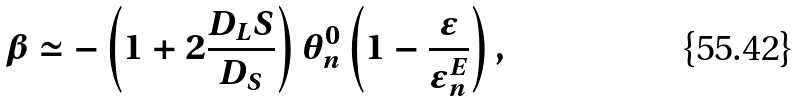Convert formula to latex. <formula><loc_0><loc_0><loc_500><loc_500>\beta \simeq - \left ( 1 + 2 \frac { D _ { L } S } { D _ { S } } \right ) \theta _ { n } ^ { 0 } \left ( 1 - \frac { \epsilon } { \epsilon _ { n } ^ { E } } \right ) ,</formula> 